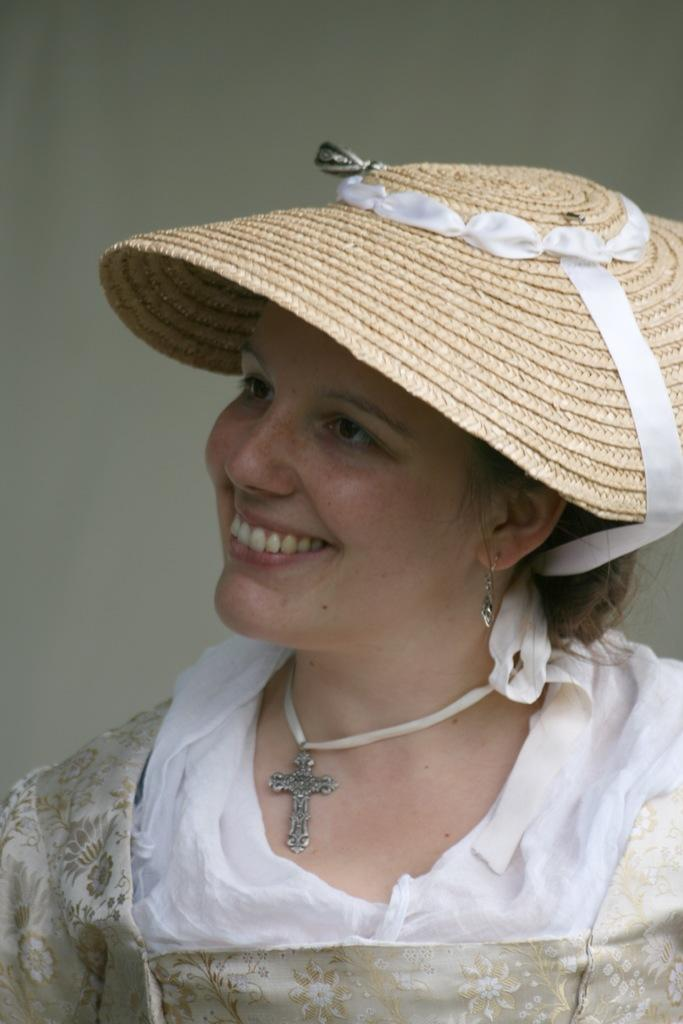Who is the main subject in the image? There is a woman in the image. What is the woman wearing? The woman is wearing a white dress and a cream hat. What accessory is the woman wearing around her neck? The woman has a cross locket chain around her neck. What is the woman's facial expression? The woman is smiling. What is the woman looking at or towards? The woman is looking towards something. What type of hydrant can be seen in the image? There is no hydrant present in the image. What trade does the woman in the image practice? The image does not provide any information about the woman's trade or profession. 